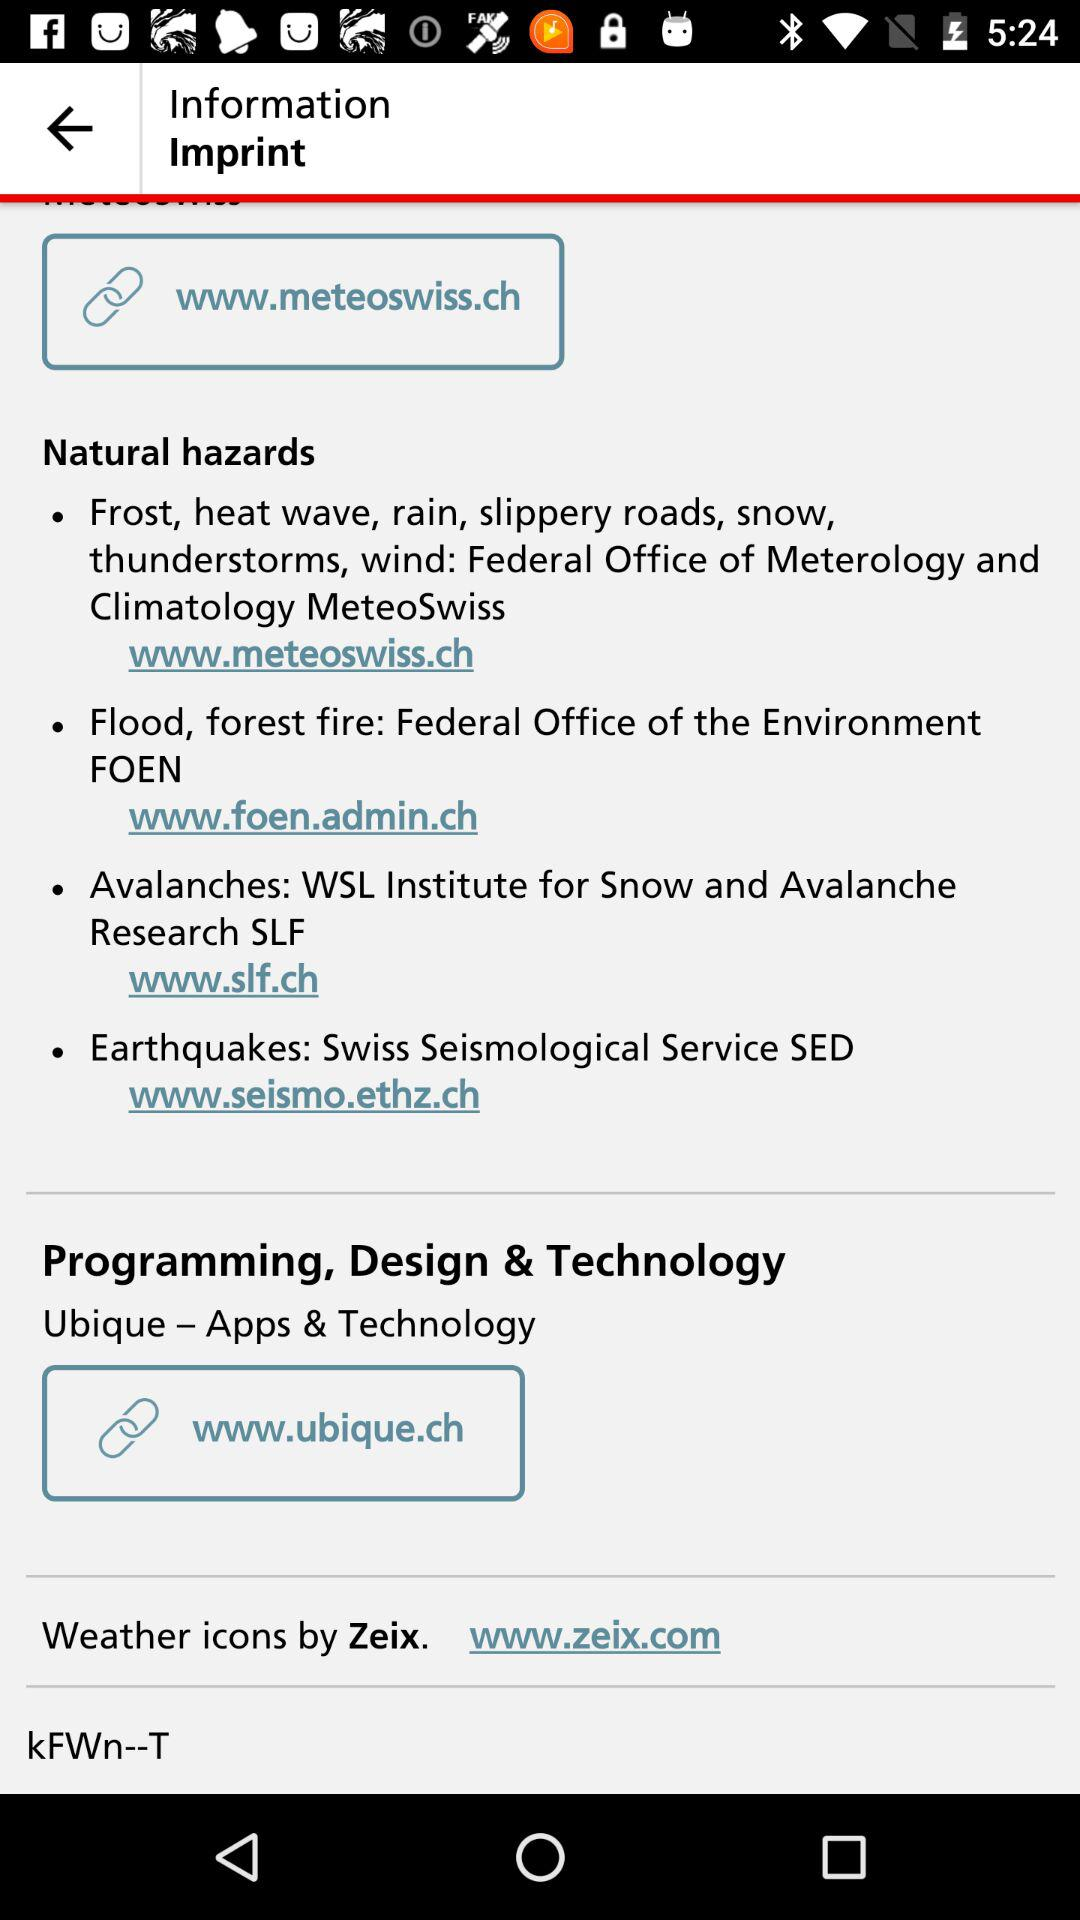What is Natural Hazards?
When the provided information is insufficient, respond with <no answer>. <no answer> 